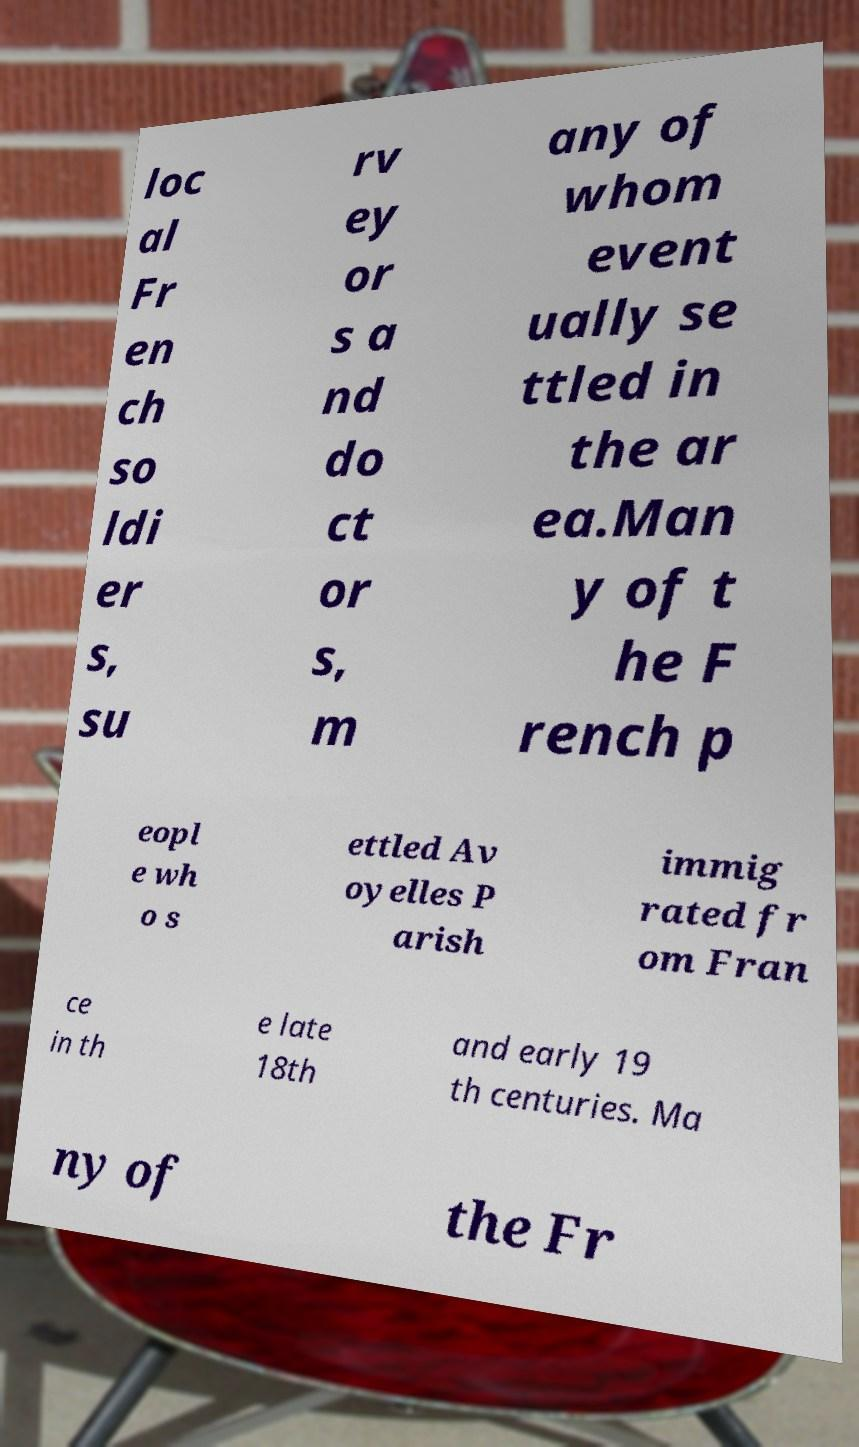Can you read and provide the text displayed in the image?This photo seems to have some interesting text. Can you extract and type it out for me? loc al Fr en ch so ldi er s, su rv ey or s a nd do ct or s, m any of whom event ually se ttled in the ar ea.Man y of t he F rench p eopl e wh o s ettled Av oyelles P arish immig rated fr om Fran ce in th e late 18th and early 19 th centuries. Ma ny of the Fr 